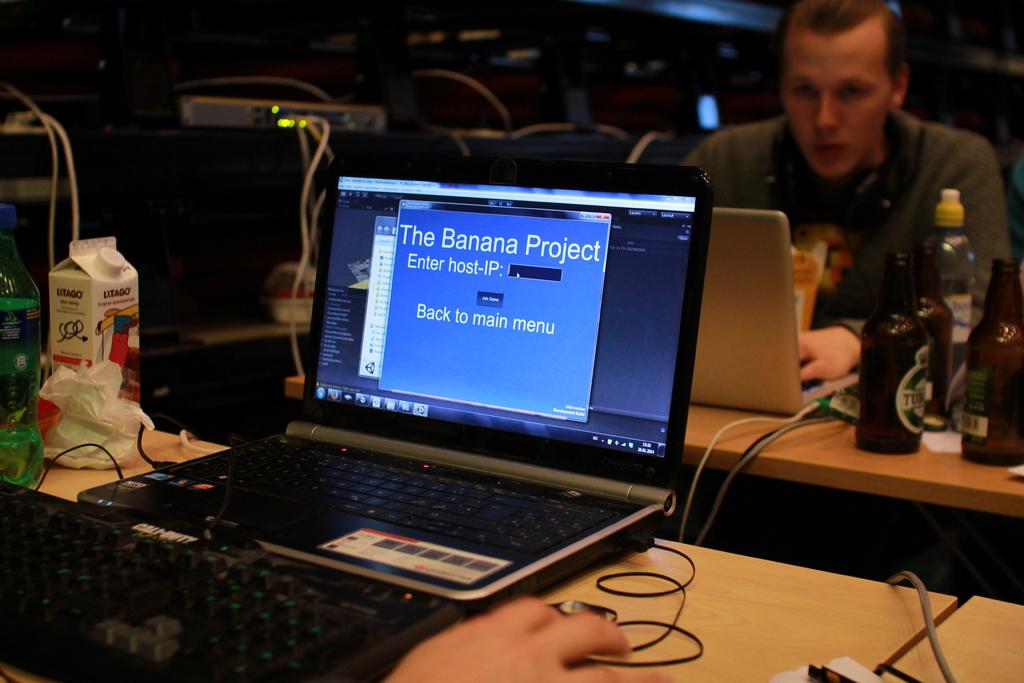What project is it?
Provide a short and direct response. The banana project. What has to be entered here?
Make the answer very short. Host-ip. 